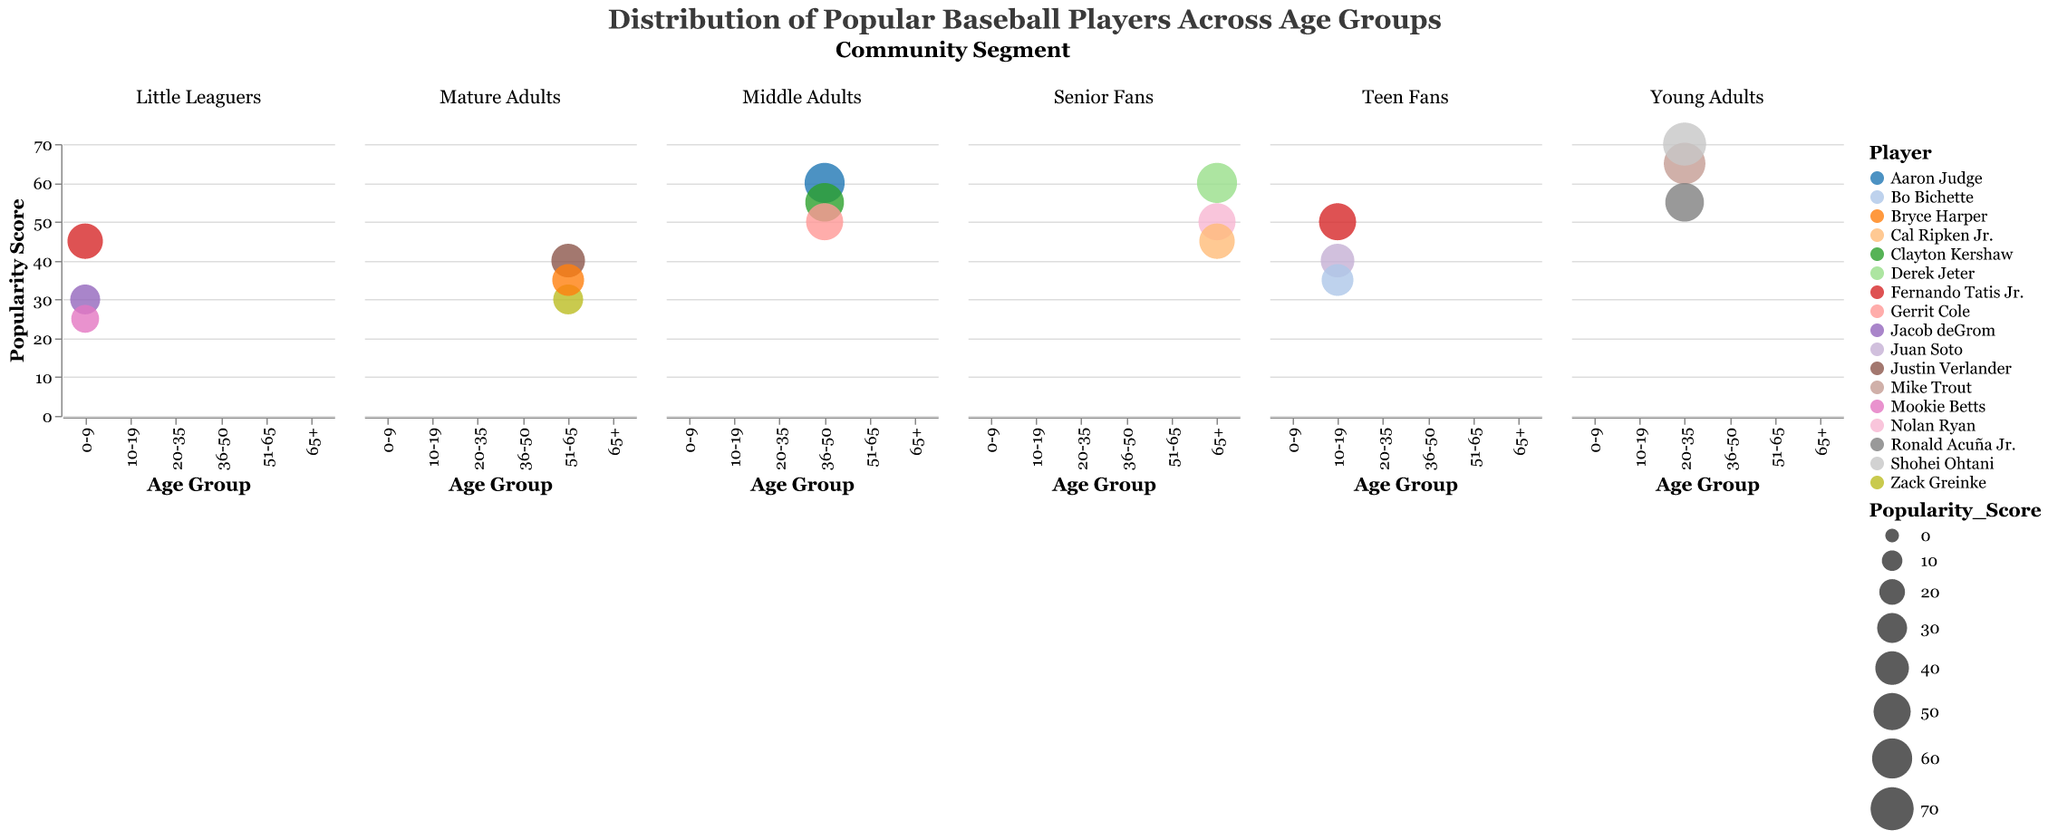What is the title of the chart? The title of the chart is located at the top and prominently displayed. It reads: "Distribution of Popular Baseball Players Across Age Groups".
Answer: Distribution of Popular Baseball Players Across Age Groups Which player has the highest popularity score among the Little Leaguers (0-9 age group)? By examining the bubble sizes within the "Community Segment: Little Leaguers" facet, we need to find the one with the largest size. Fernando Tatis Jr. has a score of 45, which is the highest among Little Leaguers.
Answer: Fernando Tatis Jr How many players are represented in the Middle Adults (36-50) segment? The "Community Segment: Middle Adults" facet shows three bubbles, each representing one player. These players are Aaron Judge, Clayton Kershaw, and Gerrit Cole.
Answer: 3 What is the total popularity score for all players in the Senior Fans (65+) segment? To find the total, we sum the popularity scores for all bubbles in the "Community Segment: Senior Fans": Derek Jeter (60), Nolan Ryan (50), and Cal Ripken Jr. (45). The total is 60 + 50 + 45.
Answer: 155 Who is more popular among Young Adults (20-35): Mike Trout or Shohei Ohtani? Compare the popularity scores between Mike Trout (65) and Shohei Ohtani (70) within the "Community Segment: Young Adults" facet. Shohei Ohtani has a higher score.
Answer: Shohei Ohtani What is the average popularity score of players in the Teen Fans (10-19) segment? To find the average, sum the popularity scores of the players in the "Community Segment: Teen Fans" and divide by the number of players. Fernando Tatis Jr. (50), Juan Soto (40), and Bo Bichette (35). The total is 50 + 40 + 35 = 125, and there are 3 players. The average is 125 / 3.
Answer: 41.67 Which age group has the largest bubble (highest popularity score) in the entire chart? Identify the largest bubble across all facets. Shohei Ohtani, in the "Community Segment: Young Adults", has the highest score of 70.
Answer: 20-35 (Shohei Ohtani) What is the difference in popularity scores between Aaron Judge and Clayton Kershaw in the Middle Adults (36-50) segment? Subtract Clayton Kershaw's score from Aaron Judge's score. Aaron Judge has 60, and Clayton Kershaw has 55. The difference is 60 - 55.
Answer: 5 Which community segment has the highest-scoring player? Compare the highest scores in each community segment: Little Leaguers (45), Teen Fans (50), Young Adults (70), Middle Adults (60), Mature Adults (40), Senior Fans (60). The highest score is 70.
Answer: Young Adults (Shohei Ohtani) What is the combined popularity score for all players in the Little Leaguers (0-9) segment? Sum the popularity scores for the players in the "Community Segment: Little Leaguers": Jacob deGrom (30), Mookie Betts (25), and Fernando Tatis Jr. (45). The total is 30 + 25 + 45.
Answer: 100 